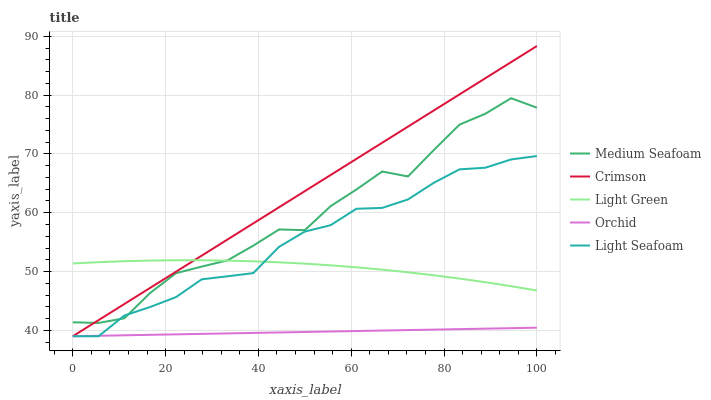Does Orchid have the minimum area under the curve?
Answer yes or no. Yes. Does Crimson have the maximum area under the curve?
Answer yes or no. Yes. Does Light Seafoam have the minimum area under the curve?
Answer yes or no. No. Does Light Seafoam have the maximum area under the curve?
Answer yes or no. No. Is Orchid the smoothest?
Answer yes or no. Yes. Is Medium Seafoam the roughest?
Answer yes or no. Yes. Is Light Seafoam the smoothest?
Answer yes or no. No. Is Light Seafoam the roughest?
Answer yes or no. No. Does Crimson have the lowest value?
Answer yes or no. Yes. Does Medium Seafoam have the lowest value?
Answer yes or no. No. Does Crimson have the highest value?
Answer yes or no. Yes. Does Light Seafoam have the highest value?
Answer yes or no. No. Is Orchid less than Medium Seafoam?
Answer yes or no. Yes. Is Medium Seafoam greater than Orchid?
Answer yes or no. Yes. Does Light Seafoam intersect Crimson?
Answer yes or no. Yes. Is Light Seafoam less than Crimson?
Answer yes or no. No. Is Light Seafoam greater than Crimson?
Answer yes or no. No. Does Orchid intersect Medium Seafoam?
Answer yes or no. No. 